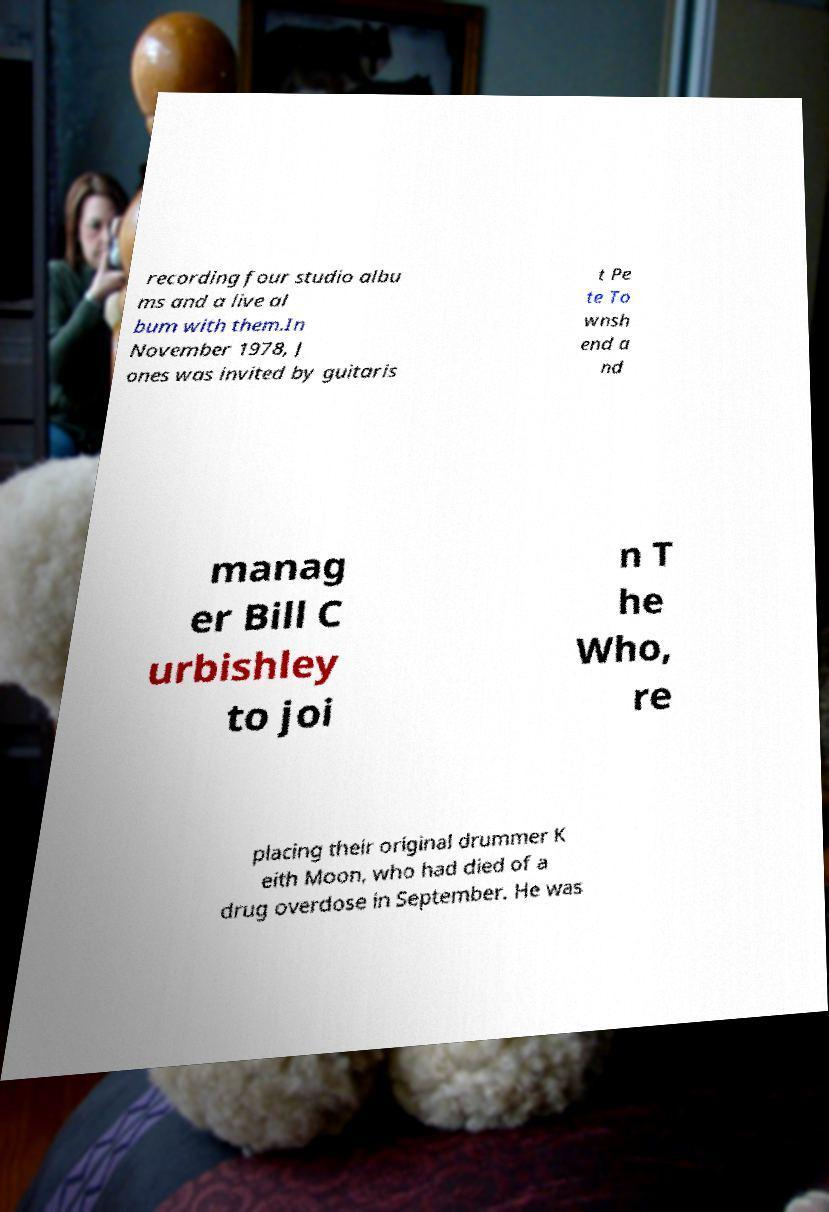Could you extract and type out the text from this image? recording four studio albu ms and a live al bum with them.In November 1978, J ones was invited by guitaris t Pe te To wnsh end a nd manag er Bill C urbishley to joi n T he Who, re placing their original drummer K eith Moon, who had died of a drug overdose in September. He was 